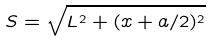Convert formula to latex. <formula><loc_0><loc_0><loc_500><loc_500>S = \sqrt { L ^ { 2 } + ( x + a / 2 ) ^ { 2 } }</formula> 